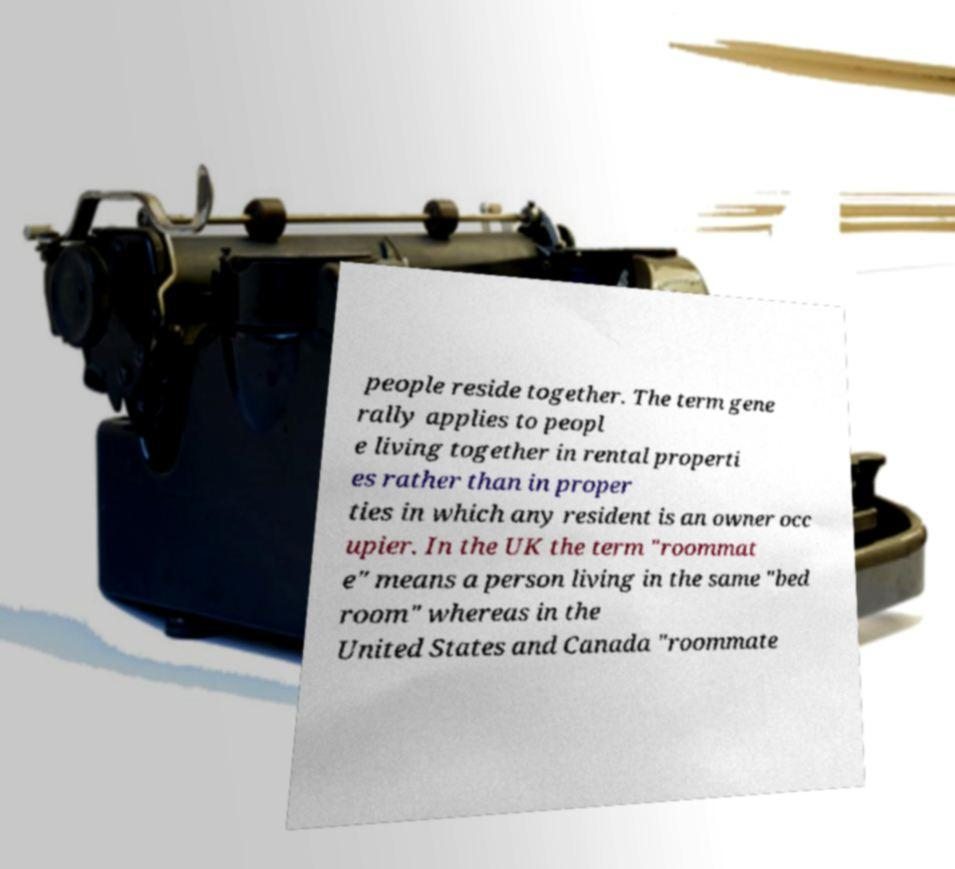For documentation purposes, I need the text within this image transcribed. Could you provide that? people reside together. The term gene rally applies to peopl e living together in rental properti es rather than in proper ties in which any resident is an owner occ upier. In the UK the term "roommat e" means a person living in the same "bed room" whereas in the United States and Canada "roommate 